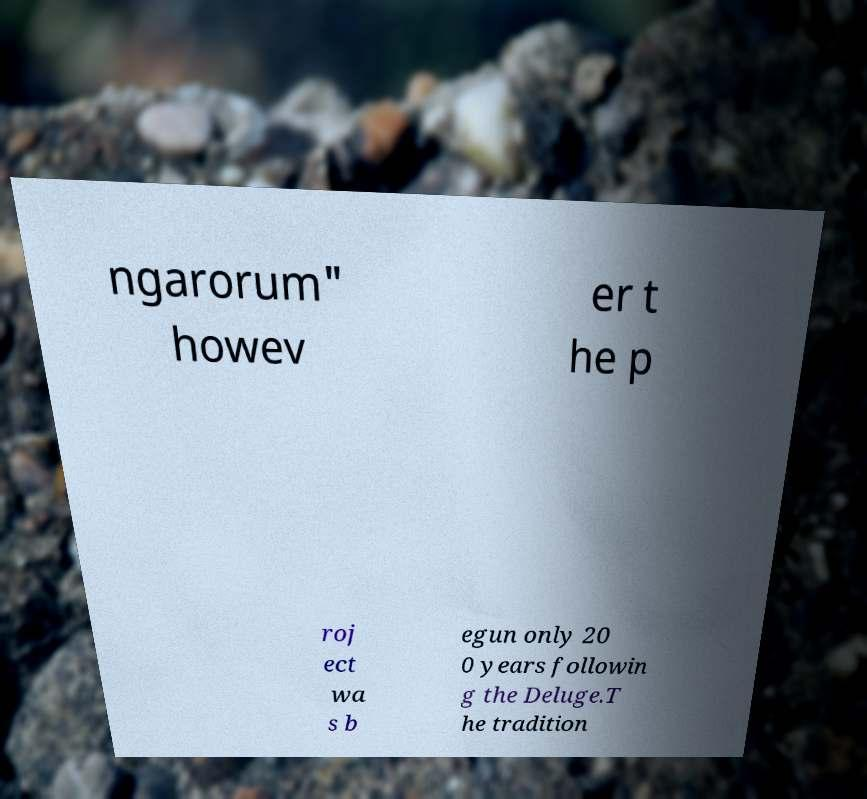Can you read and provide the text displayed in the image?This photo seems to have some interesting text. Can you extract and type it out for me? ngarorum" howev er t he p roj ect wa s b egun only 20 0 years followin g the Deluge.T he tradition 